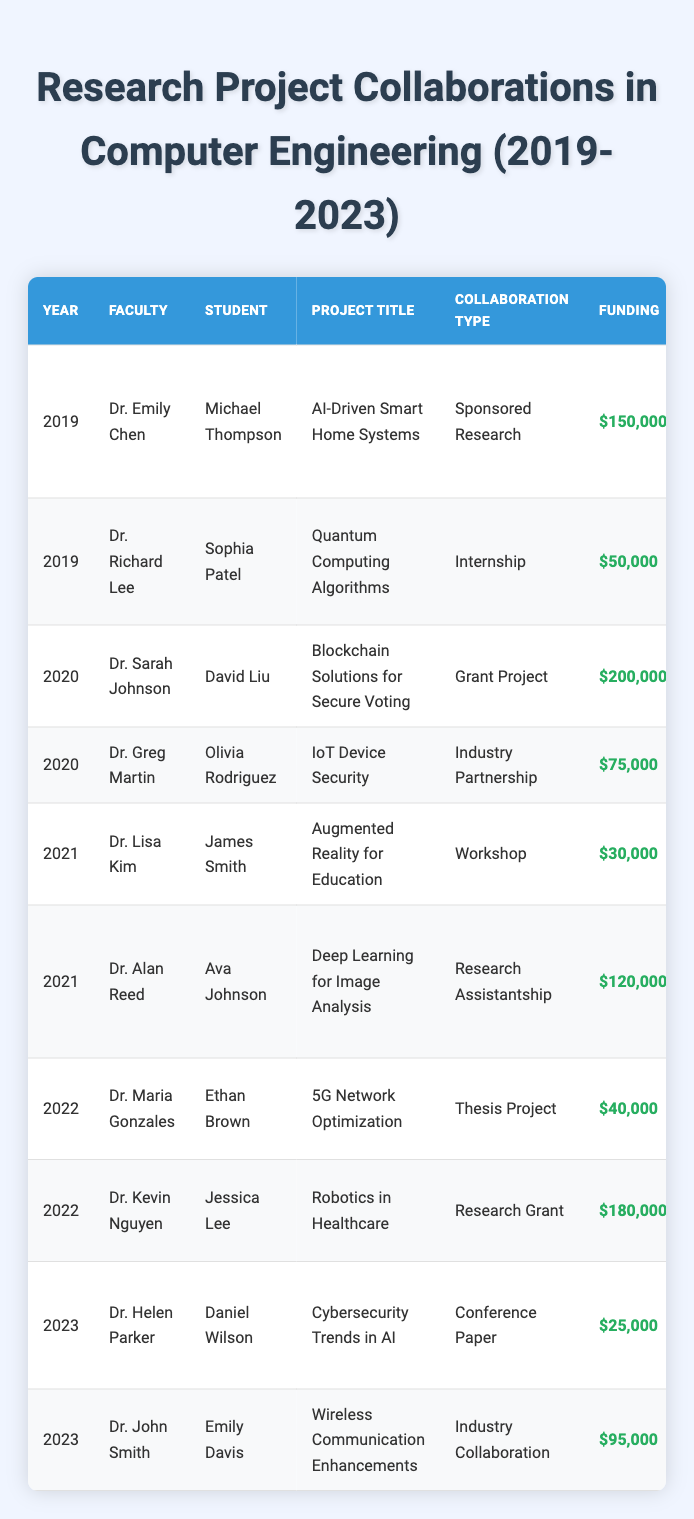What is the project title associated with Dr. Greg Martin in 2020? In the table, I look for the entry where Dr. Greg Martin is listed as the faculty and find the year 2020. The corresponding project title is "IoT Device Security."
Answer: IoT Device Security How much funding was received for the project "Blockchain Solutions for Secure Voting"? I locate the entry for the project titled "Blockchain Solutions for Secure Voting" and see that the funding amount listed is $200,000.
Answer: $200,000 What was the outcome of the project led by Dr. Emily Chen in 2019? I find Dr. Emily Chen's entry for the year 2019, which indicates that the outcome of the project "AI-Driven Smart Home Systems" is "Published in IEEE Transactions on Smart Grid."
Answer: Published in IEEE Transactions on Smart Grid Was there any collaboration involving a student named Daniel Wilson? I check the table for any entries containing the name Daniel Wilson and find that he is associated with Dr. Helen Parker's project in 2023. Thus, there is a collaboration involving him.
Answer: Yes Which collaboration type had the highest funding in 2020? I look at the year 2020 and see two entries. The funding amounts are $200,000 for "Grant Project" and $75,000 for "Industry Partnership." The highest funding is thus from "Grant Project."
Answer: Grant Project What was the total funding secured for the projects conducted in 2021? I review the entries for the year 2021, which are $30,000 for "Workshop" and $120,000 for "Research Assistantship." Adding these together (30,000 + 120,000), the total funding is $150,000.
Answer: $150,000 Which student worked on the "Robotics in Healthcare" project, and what was the funding amount? I find the entry for the project "Robotics in Healthcare," which lists Jessica Lee as the student and shows a funding amount of $180,000.
Answer: Jessica Lee, $180,000 What is the average funding amount for the projects listed in 2022? I look through the 2022 entries, which show funding amounts of $40,000 and $180,000. Summing these (40,000 + 180,000 = 220,000) and dividing by the number of projects (2) gives me an average funding of $110,000.
Answer: $110,000 Which faculty member had a project outcome related to patents? I check the table for project outcomes that mention patents. The outcome "Patent filed" is related to Dr. Greg Martin's project in 2020, "IoT Device Security."
Answer: Dr. Greg Martin In which year did the project "Cybersecurity Trends in AI" occur, and what type of collaboration was it? I find "Cybersecurity Trends in AI" listed under the 2023 entries. The collaboration type is "Conference Paper."
Answer: 2023, Conference Paper 